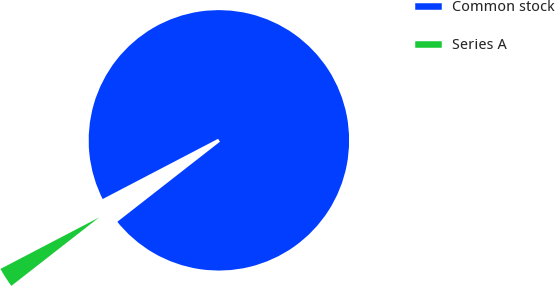<chart> <loc_0><loc_0><loc_500><loc_500><pie_chart><fcel>Common stock<fcel>Series A<nl><fcel>97.11%<fcel>2.89%<nl></chart> 